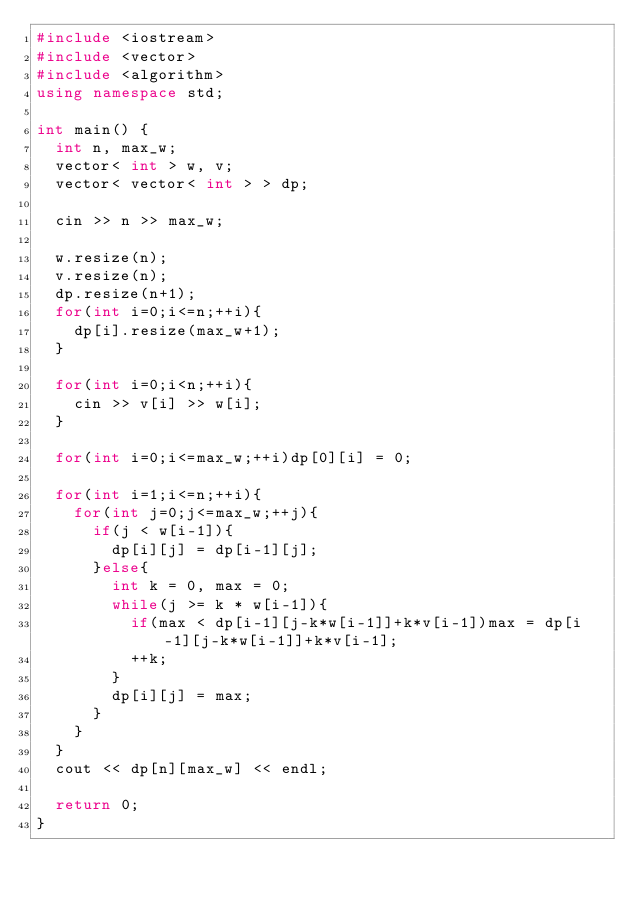Convert code to text. <code><loc_0><loc_0><loc_500><loc_500><_C++_>#include <iostream>
#include <vector>
#include <algorithm>
using namespace std;

int main() {
	int n, max_w;
	vector< int > w, v;
	vector< vector< int > > dp;
	
	cin >> n >> max_w;
	
	w.resize(n);
	v.resize(n);
	dp.resize(n+1);
	for(int i=0;i<=n;++i){
		dp[i].resize(max_w+1);
	}
	
	for(int i=0;i<n;++i){
		cin >> v[i] >> w[i];
	}
	
	for(int i=0;i<=max_w;++i)dp[0][i] = 0;
	
	for(int i=1;i<=n;++i){
		for(int j=0;j<=max_w;++j){
			if(j < w[i-1]){
				dp[i][j] = dp[i-1][j];
			}else{
				int k = 0, max = 0;
				while(j >= k * w[i-1]){
					if(max < dp[i-1][j-k*w[i-1]]+k*v[i-1])max = dp[i-1][j-k*w[i-1]]+k*v[i-1];
					++k;
				}
				dp[i][j] = max;
			}
		}
	}
	cout << dp[n][max_w] << endl;
	
	return 0;
}</code> 